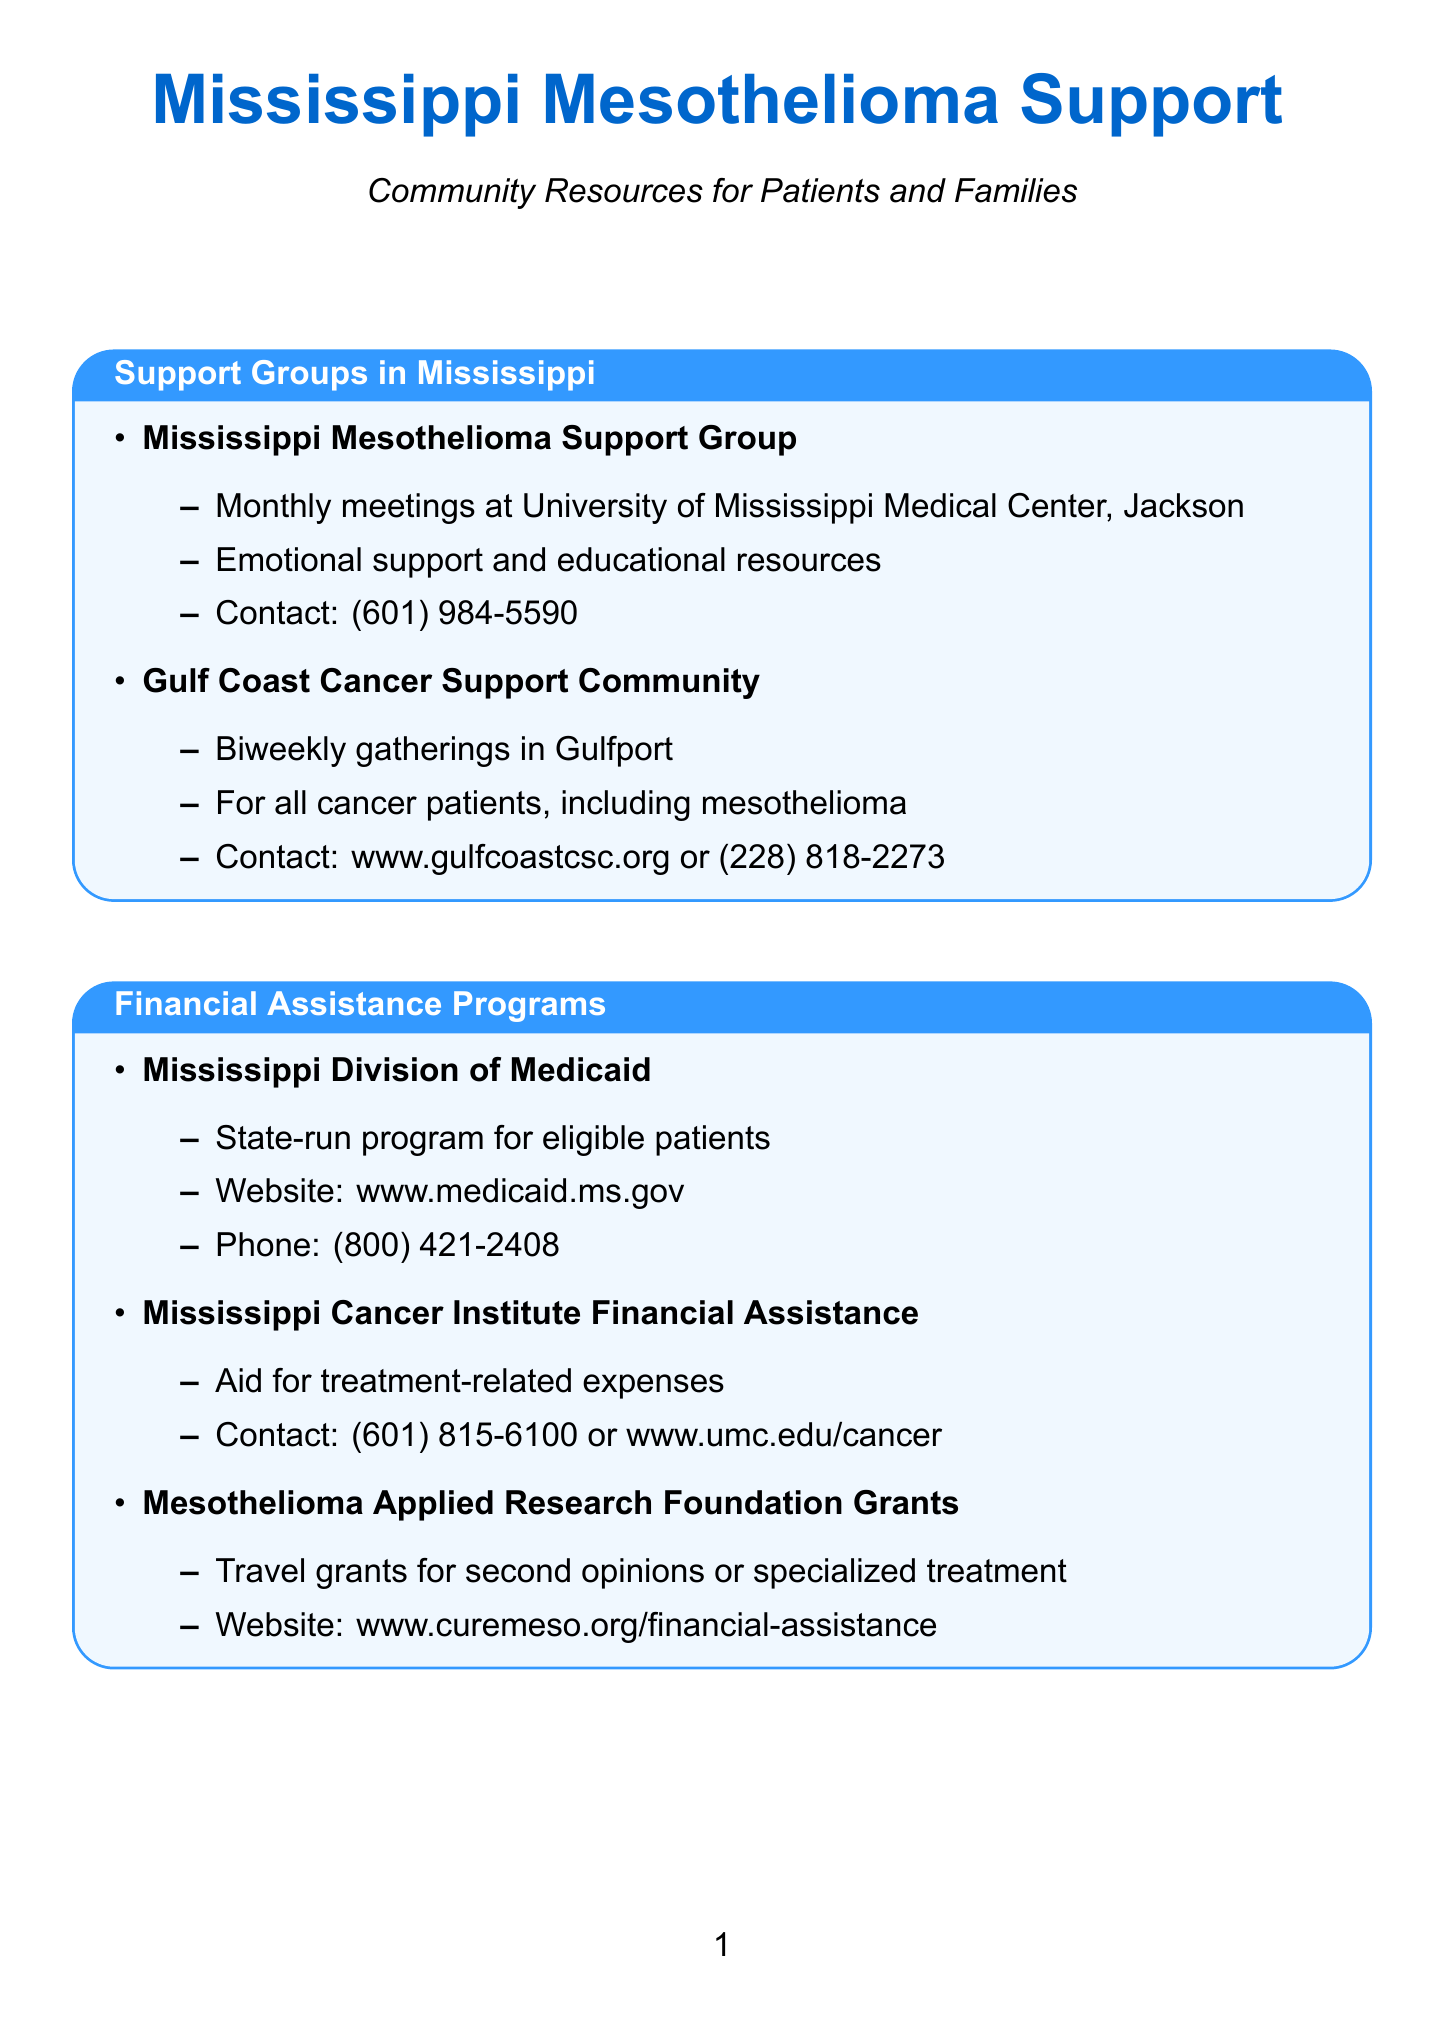what is the name of the support group in Jackson? The name of the support group in Jackson is mentioned in the section about support groups, specifically at the University of Mississippi Medical Center.
Answer: Mississippi Mesothelioma Support Group how often does the Gulf Coast Cancer Support Community meet? The frequency of meetings for the Gulf Coast Cancer Support Community is specified in the support groups section.
Answer: Biweekly what is the contact number for the Mississippi Division of Medicaid? The contact number for the Mississippi Division of Medicaid is provided in the financial assistance section.
Answer: (800) 421-2408 which organization provides transportation to cancer-related medical appointments? This organization is listed in the transportation assistance section and is dedicated to helping cancer patients.
Answer: American Cancer Society Road To Recovery how many local treatment centers are mentioned in the newsletter? The number of local treatment centers can be counted from the local treatment centers section.
Answer: 2 which center is located in Tupelo? The location of the center in Tupelo is specified in the section about local treatment centers.
Answer: North Mississippi Medical Center Cancer Care what type of legal services does the Mississippi Volunteer Lawyers Project provide? The type of legal services offered by the Mississippi Volunteer Lawyers Project is described in the legal resources section.
Answer: Pro bono legal services how can one contact the Mississippi Center for Justice? The contact information for the Mississippi Center for Justice is listed in the legal resources section.
Answer: (601) 352-2269 what is the primary purpose of the Mesothelioma Applied Research Foundation Grants? The purpose of the grants is defined in the financial assistance programs section.
Answer: Travel grants for mesothelioma patients 